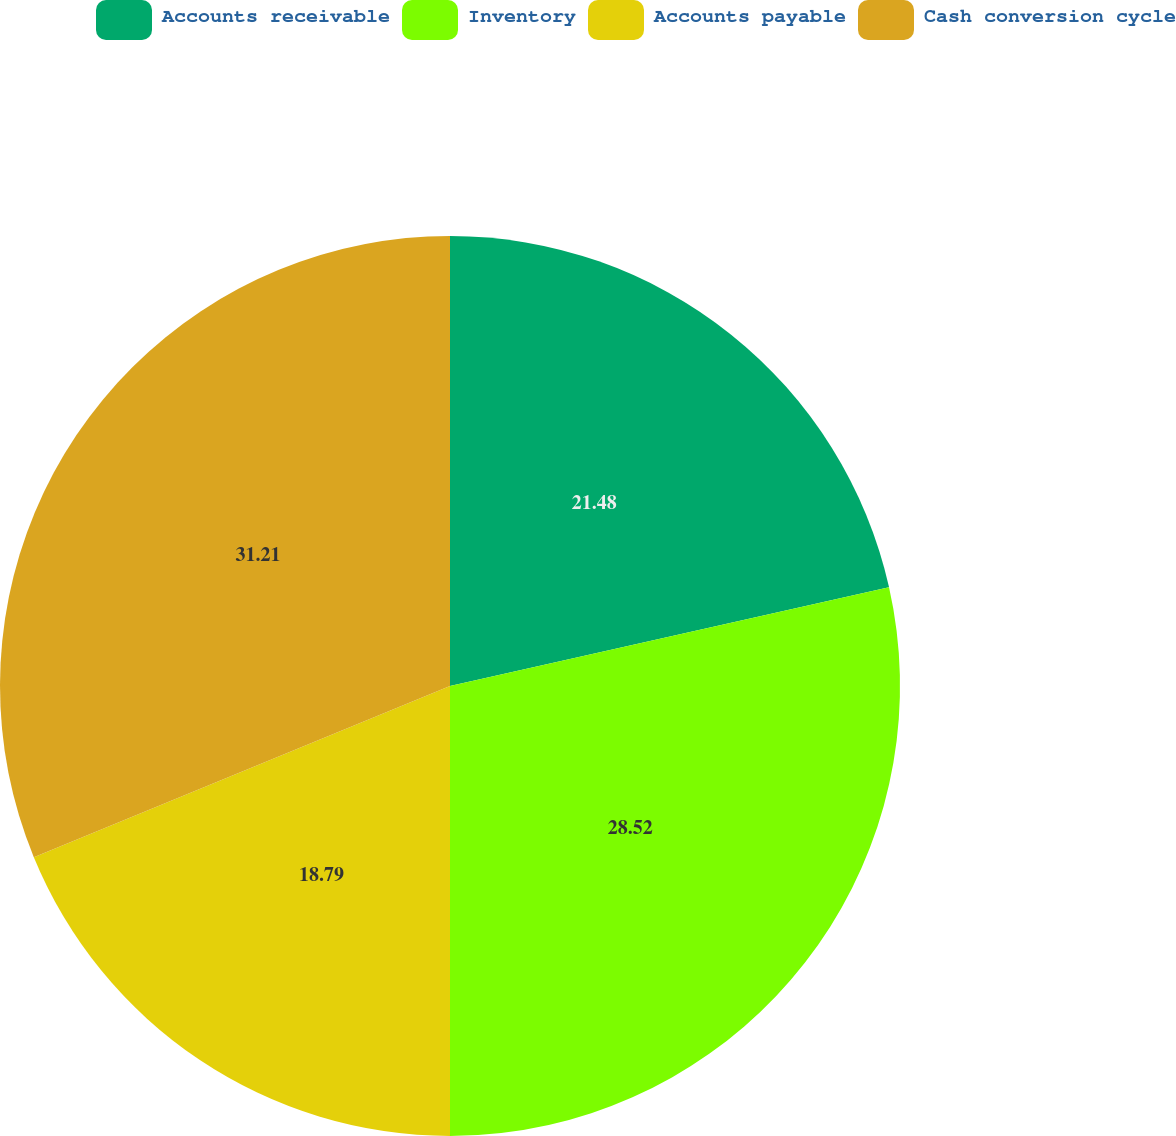Convert chart to OTSL. <chart><loc_0><loc_0><loc_500><loc_500><pie_chart><fcel>Accounts receivable<fcel>Inventory<fcel>Accounts payable<fcel>Cash conversion cycle<nl><fcel>21.48%<fcel>28.52%<fcel>18.79%<fcel>31.21%<nl></chart> 